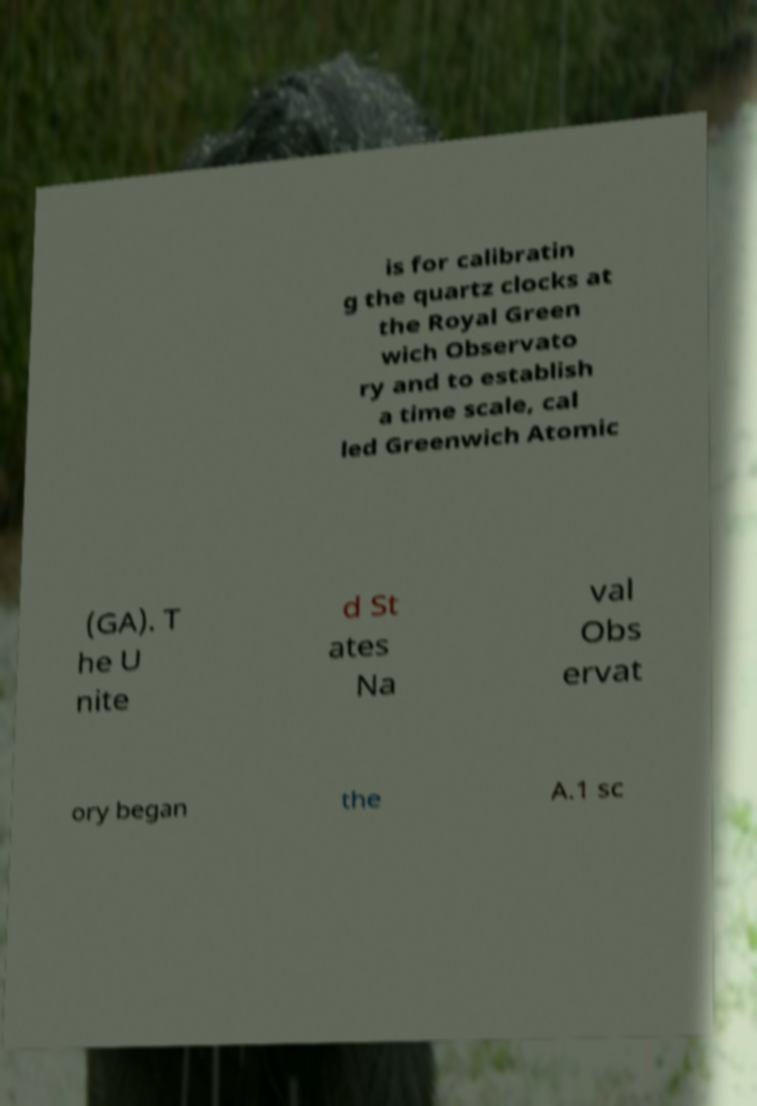What messages or text are displayed in this image? I need them in a readable, typed format. is for calibratin g the quartz clocks at the Royal Green wich Observato ry and to establish a time scale, cal led Greenwich Atomic (GA). T he U nite d St ates Na val Obs ervat ory began the A.1 sc 